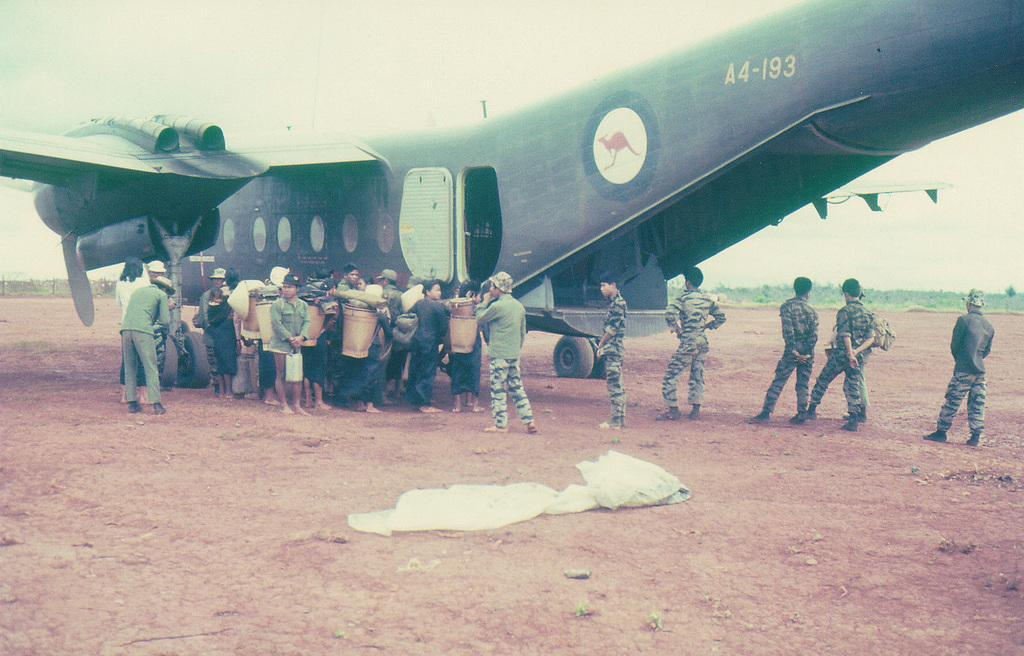In one or two sentences, can you explain what this image depicts? This looks like an airplane with a door and the windows. There are groups of people standing. Among them few people are holding the buckets. This looks like a cloth. 